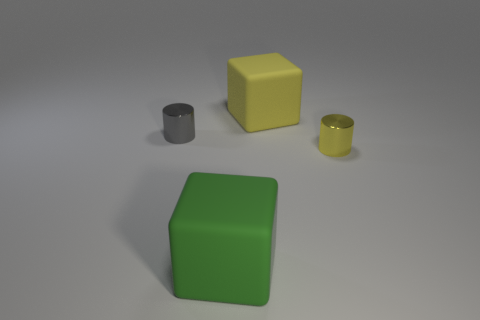Add 1 large matte cubes. How many objects exist? 5 Subtract all yellow blocks. How many blocks are left? 1 Add 1 yellow things. How many yellow things are left? 3 Add 4 big yellow rubber cylinders. How many big yellow rubber cylinders exist? 4 Subtract 0 purple balls. How many objects are left? 4 Subtract all brown cylinders. Subtract all red balls. How many cylinders are left? 2 Subtract all red things. Subtract all big green objects. How many objects are left? 3 